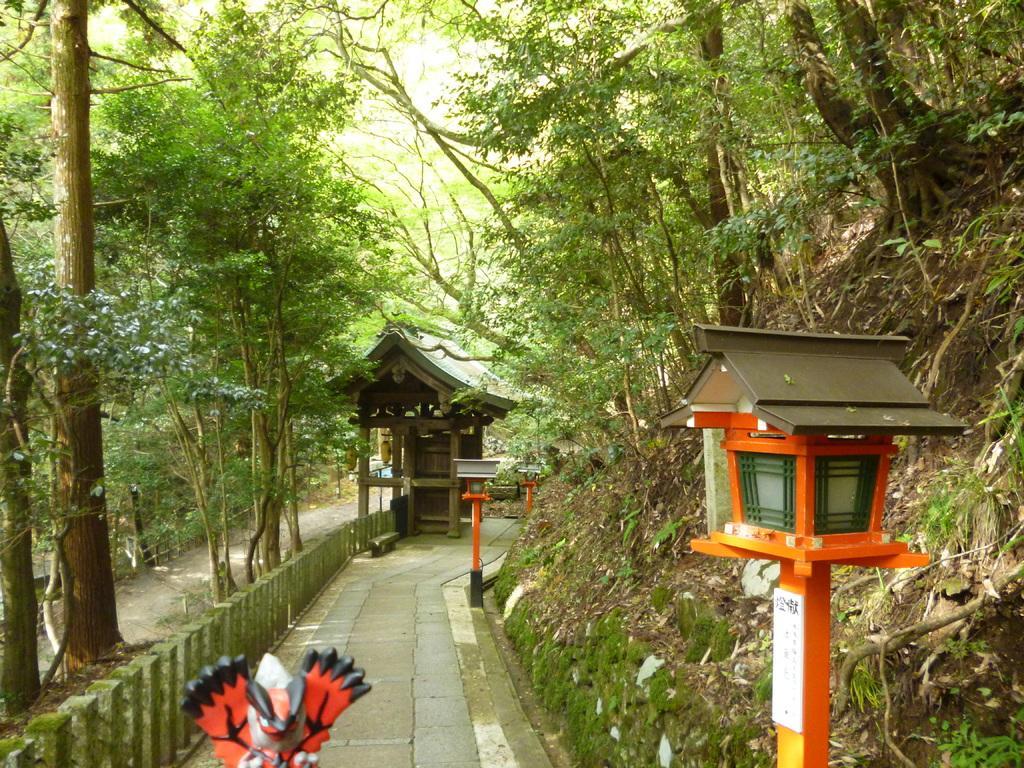Describe this image in one or two sentences. In this picture I can see the wooden hut. On the right I can see the mountain. In the left I can see many trees, plants and grass. In the bottom right I can see the light. At the top I can see the sky. 